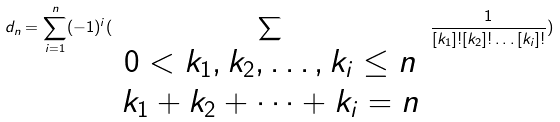<formula> <loc_0><loc_0><loc_500><loc_500>d _ { n } = \sum _ { i = 1 } ^ { n } ( - 1 ) ^ { i } ( \sum _ { \begin{array} { c } 0 < k _ { 1 } , k _ { 2 } , \dots , k _ { i } \leq n \\ k _ { 1 } + k _ { 2 } + \dots + k _ { i } = n \end{array} } \frac { 1 } { [ k _ { 1 } ] ! [ k _ { 2 } ] ! \dots [ k _ { i } ] ! } )</formula> 